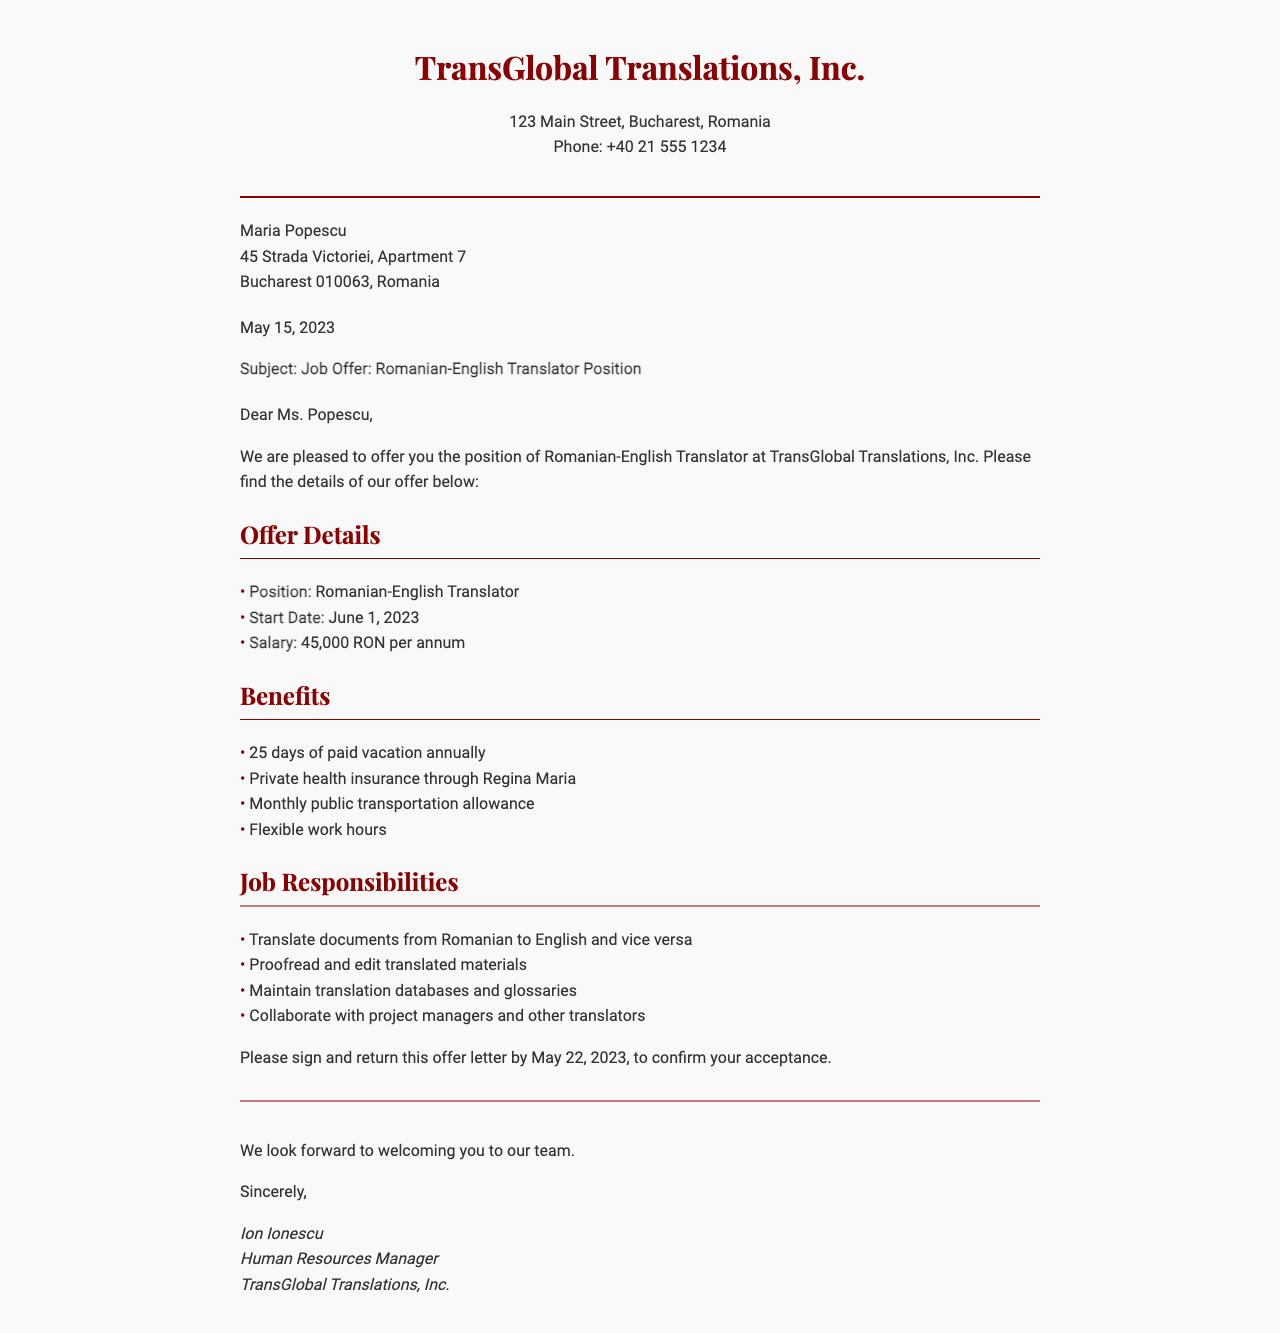What is the name of the company? The document states that the company is TransGlobal Translations, Inc.
Answer: TransGlobal Translations, Inc What is the position offered? The document specifies that the position offered is Romanian-English Translator.
Answer: Romanian-English Translator What is the start date of the position? The start date mentioned in the document is June 1, 2023.
Answer: June 1, 2023 How much is the salary? The document indicates the salary as 45,000 RON per annum.
Answer: 45,000 RON per annum How many days of paid vacation are provided? The document states that employees receive 25 days of paid vacation annually.
Answer: 25 days What type of health insurance is included? The offer includes private health insurance through Regina Maria.
Answer: Regina Maria What is one responsibility of the job? The document lists translating documents from Romanian to English and vice versa as one job responsibility.
Answer: Translate documents from Romanian to English and vice versa By what date should the offer letter be signed and returned? The document specifies that the offer letter should be signed and returned by May 22, 2023.
Answer: May 22, 2023 Who is the Human Resources Manager? The document states that the Human Resources Manager is Ion Ionescu.
Answer: Ion Ionescu 